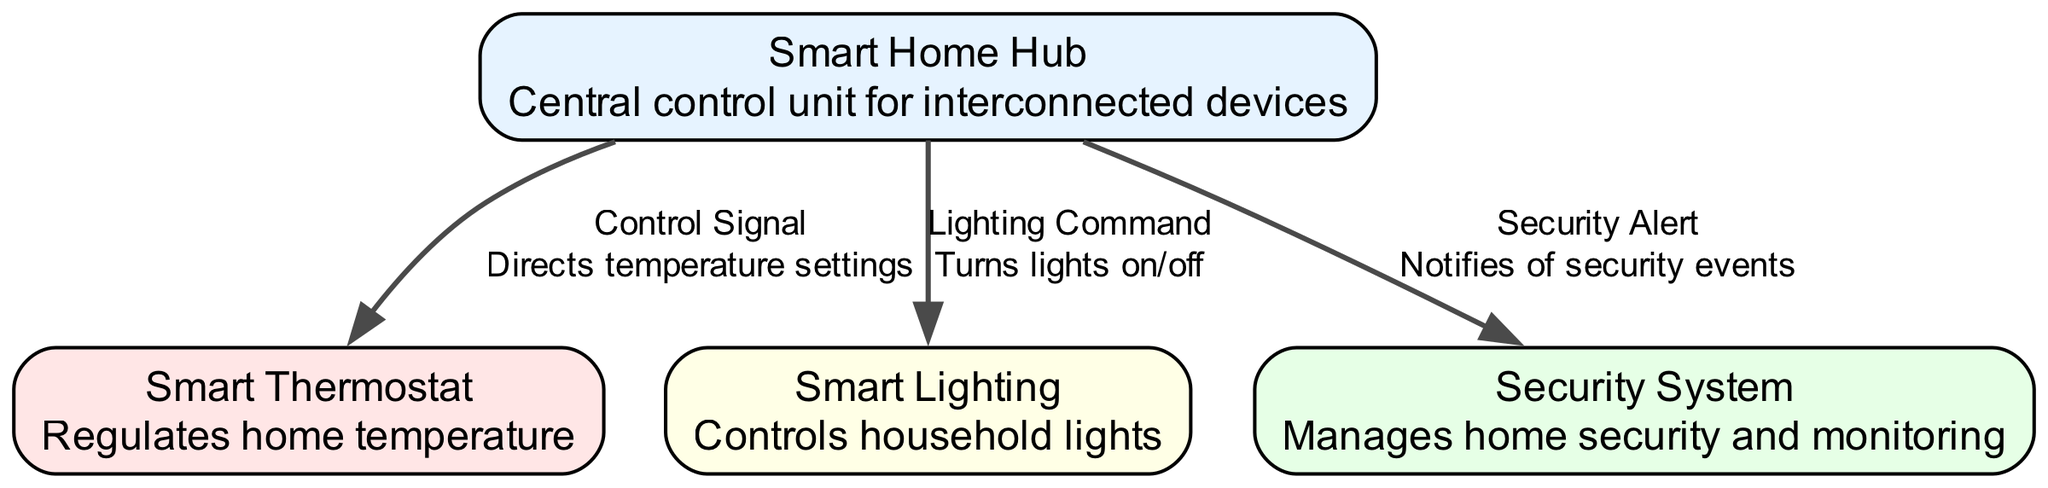What is the central control unit in the smart home architecture? The diagram labels the central control unit as "Smart Home Hub." It is the primary device managing all the interconnected smart devices.
Answer: Smart Home Hub How many devices are interconnected with the Smart Home Hub? The diagram shows three interconnected devices connected to the Smart Home Hub: Smart Thermostat, Smart Lighting, and Security System.
Answer: Three What control signal does the Smart Home Hub send to the Smart Thermostat? The diagram specifies that the Smart Home Hub sends a "Control Signal" to the Smart Thermostat, indicating that it directs temperature settings.
Answer: Control Signal Which device is responsible for managing home security? According to the diagram, the "Security System" is the device that manages home security and monitoring.
Answer: Security System What describes the connection between the Smart Home Hub and the Smart Lighting? The diagram indicates that the edge connecting these two nodes is labeled as "Lighting Command," which signals that it turns lights on/off.
Answer: Lighting Command Which device's label is associated with a light red color? The diagram's node for "Smart Thermostat" is represented with a light red color, indicating its function related to temperature management.
Answer: Smart Thermostat What type of command goes from the Smart Home Hub to the Security System? The diagram illustrates that a "Security Alert" is sent from the Smart Home Hub to the Security System, which notifies of security events.
Answer: Security Alert What is the purpose of the Smart Lighting device in the diagram? The description associated with the Smart Lighting indicates that it controls household lights, meaning its primary function is for lighting management.
Answer: Controls household lights How many types of connections exist in the diagram? The diagram includes three distinct types of edges (or connections) from the Smart Home Hub to the other devices, which indicates relationships of control between them.
Answer: Three 